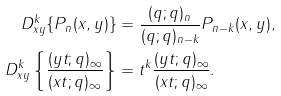<formula> <loc_0><loc_0><loc_500><loc_500>D _ { x y } ^ { k } \{ P _ { n } ( x , y ) \} & = \frac { ( q ; q ) _ { n } } { ( q ; q ) _ { n - k } } P _ { n - k } ( x , y ) , \\ D _ { x y } ^ { k } \left \{ \frac { ( y t ; q ) _ { \infty } } { ( x t ; q ) _ { \infty } } \right \} & = t ^ { k } \frac { ( y t ; q ) _ { \infty } } { ( x t ; q ) _ { \infty } } .</formula> 